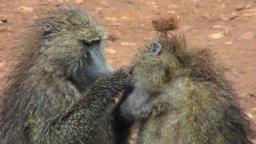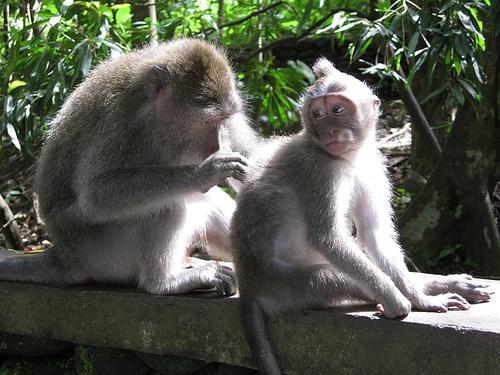The first image is the image on the left, the second image is the image on the right. Assess this claim about the two images: "There are exactly four apes.". Correct or not? Answer yes or no. Yes. The first image is the image on the left, the second image is the image on the right. Analyze the images presented: Is the assertion "a baboon is grooming another baboon's leg while it lays down" valid? Answer yes or no. No. 